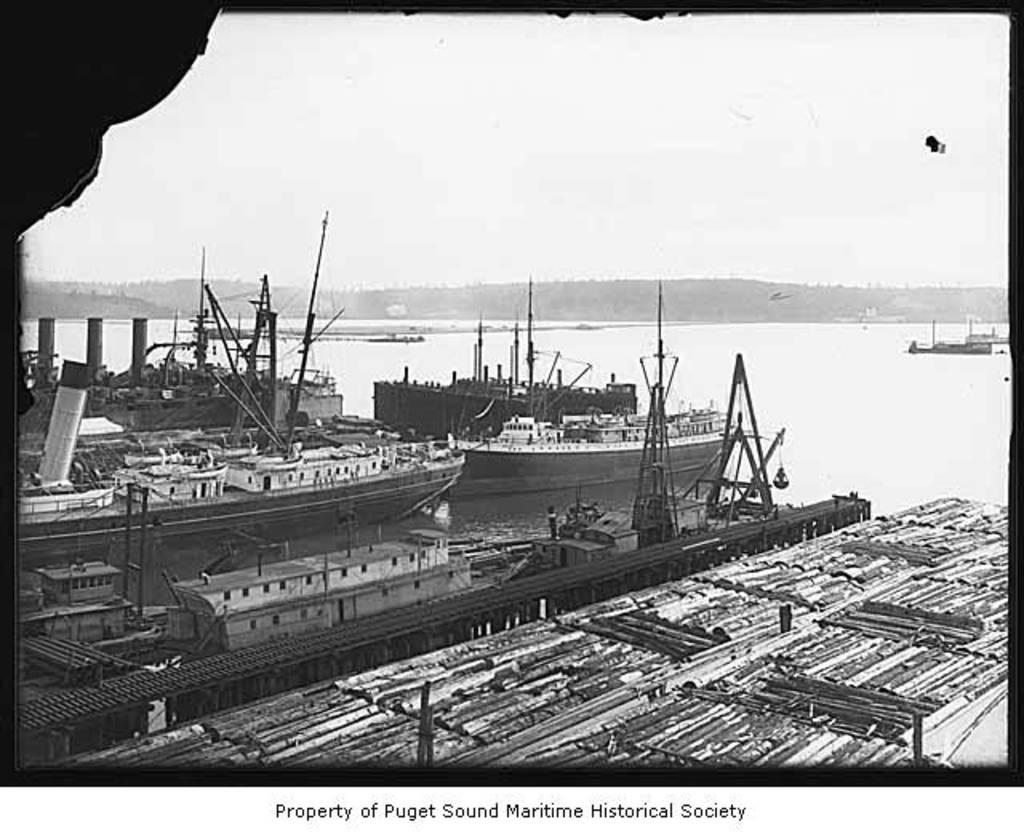What is the color scheme of the image? The image is black and white. What can be seen in the water in the image? There are ships in the image. What are the poles used for in the image? The purpose of the poles is not specified, but they are likely used for mooring or navigational purposes. What is visible in the background of the image? Hills and sky are visible in the background of the image. What is written at the bottom of the image? There is text at the bottom of the image. How many rabbits can be seen playing with a substance in the image? There are no rabbits or substances present in the image; it features ships, water, poles, hills, and sky. What type of cat is sitting on the hill in the image? There is no cat present in the image; it only features ships, water, poles, hills, and sky. 